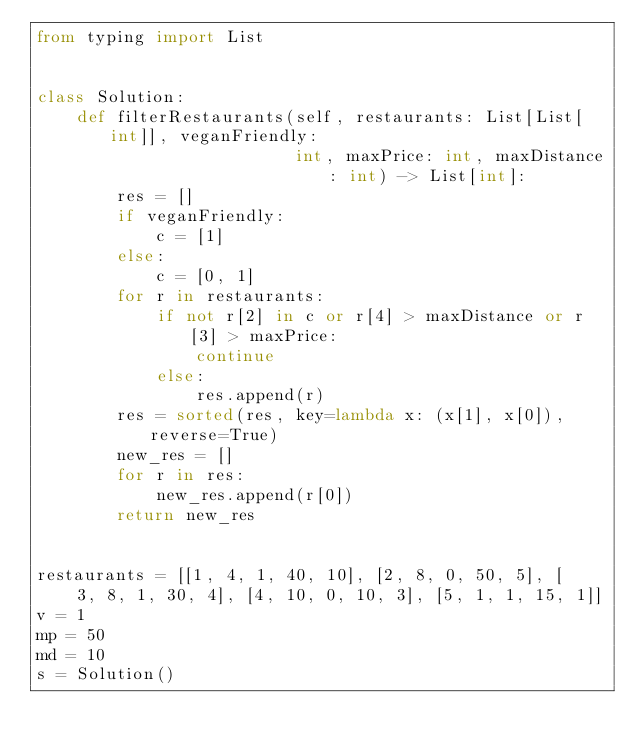<code> <loc_0><loc_0><loc_500><loc_500><_Python_>from typing import List


class Solution:
    def filterRestaurants(self, restaurants: List[List[int]], veganFriendly:
                          int, maxPrice: int, maxDistance: int) -> List[int]:
        res = []
        if veganFriendly:
            c = [1]
        else:
            c = [0, 1]
        for r in restaurants:
            if not r[2] in c or r[4] > maxDistance or r[3] > maxPrice:
                continue
            else:
                res.append(r)
        res = sorted(res, key=lambda x: (x[1], x[0]), reverse=True)
        new_res = []
        for r in res:
            new_res.append(r[0])
        return new_res


restaurants = [[1, 4, 1, 40, 10], [2, 8, 0, 50, 5], [
    3, 8, 1, 30, 4], [4, 10, 0, 10, 3], [5, 1, 1, 15, 1]]
v = 1
mp = 50
md = 10
s = Solution()</code> 